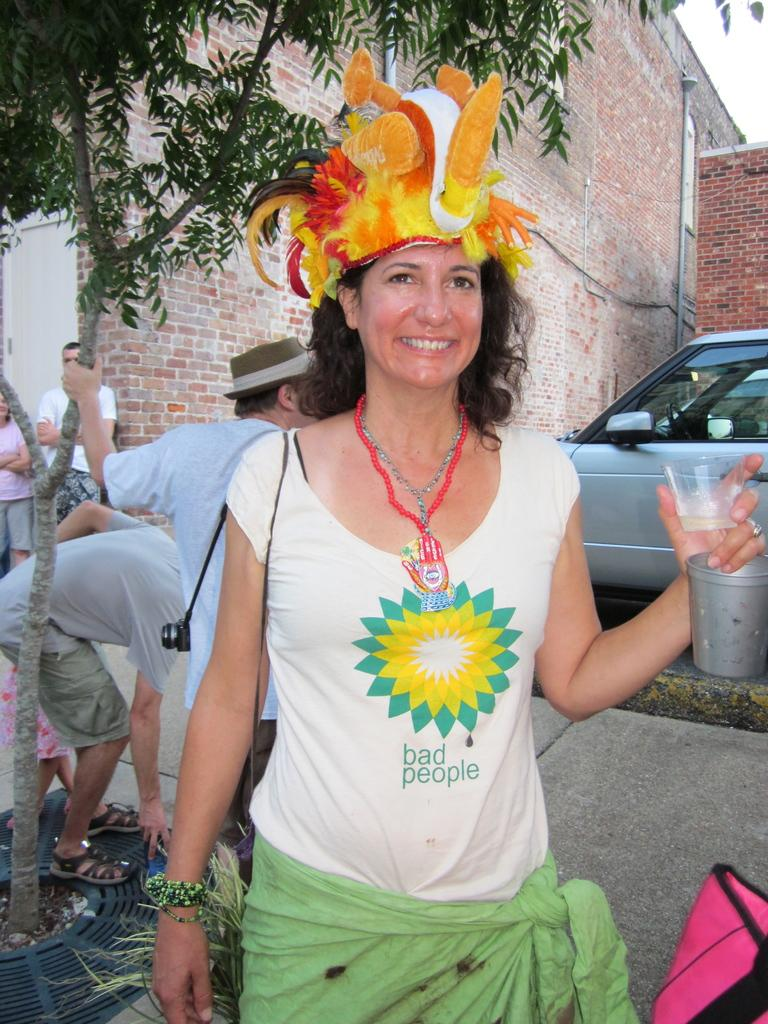What is the main subject of the image? There is a woman in the middle of the image. What is the woman doing in the image? The woman is standing and smiling. What is the woman holding in the image? The woman is holding a glass. What is the woman wearing in the image? The woman is wearing a cap. Are there any other people in the image? Yes, there are people standing behind the woman. What can be seen in the background of the image? Trees, vehicles, and buildings are visible in the image. How many eyes does the woman have on her back in the image? The woman does not have any eyes on her back in the image. What is the woman's interest in the image? The image does not provide information about the woman's interests. 